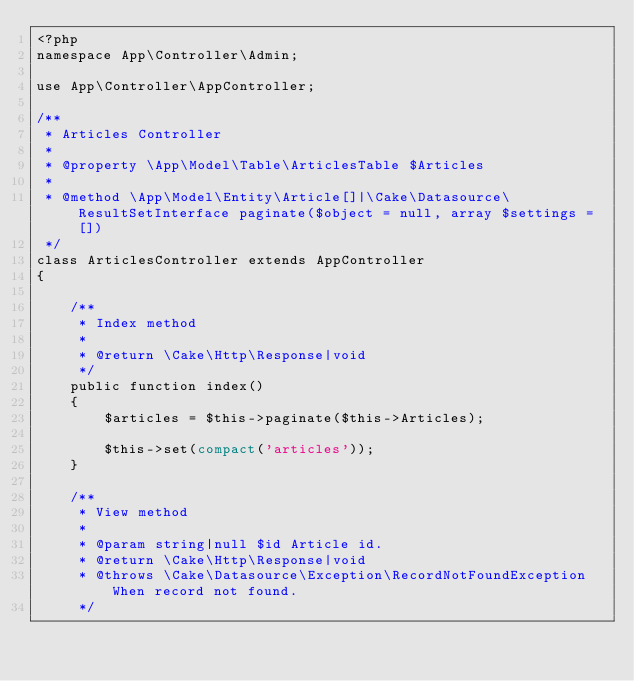<code> <loc_0><loc_0><loc_500><loc_500><_PHP_><?php
namespace App\Controller\Admin;

use App\Controller\AppController;

/**
 * Articles Controller
 *
 * @property \App\Model\Table\ArticlesTable $Articles
 *
 * @method \App\Model\Entity\Article[]|\Cake\Datasource\ResultSetInterface paginate($object = null, array $settings = [])
 */
class ArticlesController extends AppController
{

    /**
     * Index method
     *
     * @return \Cake\Http\Response|void
     */
    public function index()
    {
        $articles = $this->paginate($this->Articles);

        $this->set(compact('articles'));
    }

    /**
     * View method
     *
     * @param string|null $id Article id.
     * @return \Cake\Http\Response|void
     * @throws \Cake\Datasource\Exception\RecordNotFoundException When record not found.
     */</code> 